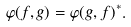Convert formula to latex. <formula><loc_0><loc_0><loc_500><loc_500>\varphi ( f , g ) = \varphi ( g , f ) ^ { * } .</formula> 